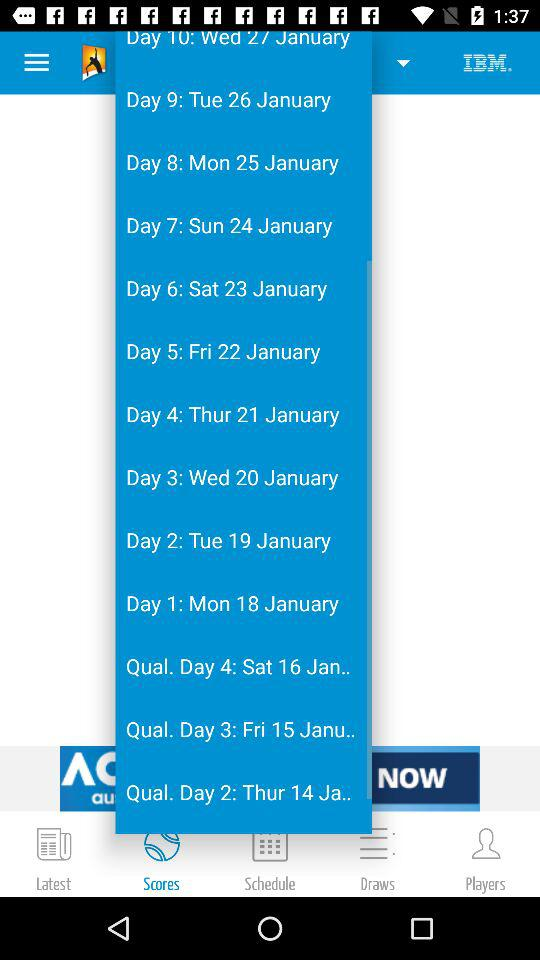What is the day on 22 January? The day on January 22 is Friday. 